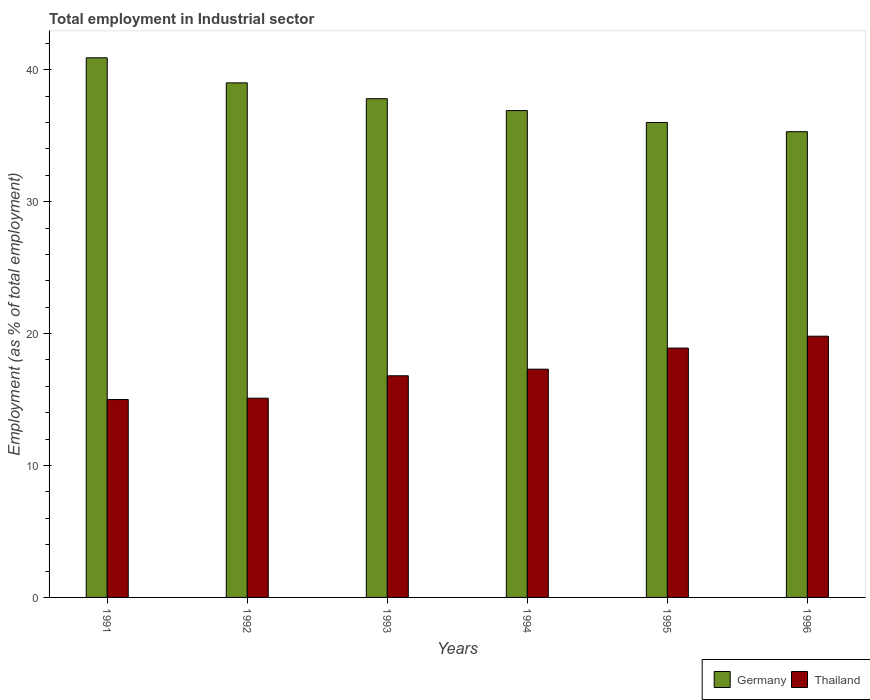How many different coloured bars are there?
Ensure brevity in your answer.  2. How many groups of bars are there?
Offer a terse response. 6. Are the number of bars per tick equal to the number of legend labels?
Offer a terse response. Yes. Are the number of bars on each tick of the X-axis equal?
Provide a short and direct response. Yes. How many bars are there on the 2nd tick from the left?
Your answer should be very brief. 2. What is the label of the 4th group of bars from the left?
Keep it short and to the point. 1994. What is the employment in industrial sector in Thailand in 1993?
Offer a very short reply. 16.8. Across all years, what is the maximum employment in industrial sector in Thailand?
Ensure brevity in your answer.  19.8. In which year was the employment in industrial sector in Thailand maximum?
Offer a terse response. 1996. In which year was the employment in industrial sector in Germany minimum?
Make the answer very short. 1996. What is the total employment in industrial sector in Thailand in the graph?
Make the answer very short. 102.9. What is the difference between the employment in industrial sector in Germany in 1992 and that in 1994?
Provide a succinct answer. 2.1. What is the difference between the employment in industrial sector in Germany in 1993 and the employment in industrial sector in Thailand in 1996?
Offer a very short reply. 18. What is the average employment in industrial sector in Thailand per year?
Ensure brevity in your answer.  17.15. In the year 1993, what is the difference between the employment in industrial sector in Germany and employment in industrial sector in Thailand?
Give a very brief answer. 21. In how many years, is the employment in industrial sector in Germany greater than 36 %?
Your answer should be very brief. 4. What is the ratio of the employment in industrial sector in Thailand in 1991 to that in 1996?
Make the answer very short. 0.76. Is the employment in industrial sector in Thailand in 1992 less than that in 1993?
Keep it short and to the point. Yes. Is the difference between the employment in industrial sector in Germany in 1991 and 1996 greater than the difference between the employment in industrial sector in Thailand in 1991 and 1996?
Your answer should be very brief. Yes. What is the difference between the highest and the second highest employment in industrial sector in Thailand?
Ensure brevity in your answer.  0.9. What is the difference between the highest and the lowest employment in industrial sector in Germany?
Give a very brief answer. 5.6. What does the 1st bar from the left in 1992 represents?
Make the answer very short. Germany. Are all the bars in the graph horizontal?
Give a very brief answer. No. How many years are there in the graph?
Offer a very short reply. 6. What is the difference between two consecutive major ticks on the Y-axis?
Keep it short and to the point. 10. Are the values on the major ticks of Y-axis written in scientific E-notation?
Ensure brevity in your answer.  No. Does the graph contain grids?
Make the answer very short. No. Where does the legend appear in the graph?
Keep it short and to the point. Bottom right. How many legend labels are there?
Your answer should be very brief. 2. How are the legend labels stacked?
Make the answer very short. Horizontal. What is the title of the graph?
Offer a terse response. Total employment in Industrial sector. What is the label or title of the Y-axis?
Your response must be concise. Employment (as % of total employment). What is the Employment (as % of total employment) of Germany in 1991?
Keep it short and to the point. 40.9. What is the Employment (as % of total employment) of Thailand in 1991?
Offer a terse response. 15. What is the Employment (as % of total employment) in Germany in 1992?
Provide a short and direct response. 39. What is the Employment (as % of total employment) of Thailand in 1992?
Provide a short and direct response. 15.1. What is the Employment (as % of total employment) of Germany in 1993?
Give a very brief answer. 37.8. What is the Employment (as % of total employment) of Thailand in 1993?
Offer a terse response. 16.8. What is the Employment (as % of total employment) in Germany in 1994?
Keep it short and to the point. 36.9. What is the Employment (as % of total employment) of Thailand in 1994?
Offer a very short reply. 17.3. What is the Employment (as % of total employment) in Germany in 1995?
Offer a terse response. 36. What is the Employment (as % of total employment) of Thailand in 1995?
Provide a succinct answer. 18.9. What is the Employment (as % of total employment) in Germany in 1996?
Ensure brevity in your answer.  35.3. What is the Employment (as % of total employment) of Thailand in 1996?
Give a very brief answer. 19.8. Across all years, what is the maximum Employment (as % of total employment) in Germany?
Your response must be concise. 40.9. Across all years, what is the maximum Employment (as % of total employment) in Thailand?
Keep it short and to the point. 19.8. Across all years, what is the minimum Employment (as % of total employment) of Germany?
Offer a terse response. 35.3. Across all years, what is the minimum Employment (as % of total employment) in Thailand?
Make the answer very short. 15. What is the total Employment (as % of total employment) of Germany in the graph?
Ensure brevity in your answer.  225.9. What is the total Employment (as % of total employment) in Thailand in the graph?
Offer a very short reply. 102.9. What is the difference between the Employment (as % of total employment) of Germany in 1991 and that in 1992?
Your response must be concise. 1.9. What is the difference between the Employment (as % of total employment) in Germany in 1991 and that in 1993?
Keep it short and to the point. 3.1. What is the difference between the Employment (as % of total employment) of Germany in 1991 and that in 1994?
Offer a very short reply. 4. What is the difference between the Employment (as % of total employment) of Thailand in 1991 and that in 1994?
Ensure brevity in your answer.  -2.3. What is the difference between the Employment (as % of total employment) in Germany in 1991 and that in 1995?
Offer a terse response. 4.9. What is the difference between the Employment (as % of total employment) in Thailand in 1991 and that in 1995?
Make the answer very short. -3.9. What is the difference between the Employment (as % of total employment) in Germany in 1992 and that in 1993?
Make the answer very short. 1.2. What is the difference between the Employment (as % of total employment) in Thailand in 1992 and that in 1993?
Ensure brevity in your answer.  -1.7. What is the difference between the Employment (as % of total employment) in Germany in 1992 and that in 1994?
Give a very brief answer. 2.1. What is the difference between the Employment (as % of total employment) of Thailand in 1992 and that in 1996?
Your answer should be very brief. -4.7. What is the difference between the Employment (as % of total employment) of Germany in 1993 and that in 1994?
Provide a succinct answer. 0.9. What is the difference between the Employment (as % of total employment) in Germany in 1993 and that in 1995?
Give a very brief answer. 1.8. What is the difference between the Employment (as % of total employment) in Thailand in 1993 and that in 1995?
Ensure brevity in your answer.  -2.1. What is the difference between the Employment (as % of total employment) of Germany in 1993 and that in 1996?
Your answer should be very brief. 2.5. What is the difference between the Employment (as % of total employment) of Thailand in 1993 and that in 1996?
Keep it short and to the point. -3. What is the difference between the Employment (as % of total employment) in Germany in 1994 and that in 1995?
Provide a short and direct response. 0.9. What is the difference between the Employment (as % of total employment) of Germany in 1994 and that in 1996?
Keep it short and to the point. 1.6. What is the difference between the Employment (as % of total employment) of Thailand in 1994 and that in 1996?
Your answer should be compact. -2.5. What is the difference between the Employment (as % of total employment) of Thailand in 1995 and that in 1996?
Keep it short and to the point. -0.9. What is the difference between the Employment (as % of total employment) of Germany in 1991 and the Employment (as % of total employment) of Thailand in 1992?
Offer a terse response. 25.8. What is the difference between the Employment (as % of total employment) of Germany in 1991 and the Employment (as % of total employment) of Thailand in 1993?
Ensure brevity in your answer.  24.1. What is the difference between the Employment (as % of total employment) of Germany in 1991 and the Employment (as % of total employment) of Thailand in 1994?
Give a very brief answer. 23.6. What is the difference between the Employment (as % of total employment) in Germany in 1991 and the Employment (as % of total employment) in Thailand in 1996?
Keep it short and to the point. 21.1. What is the difference between the Employment (as % of total employment) in Germany in 1992 and the Employment (as % of total employment) in Thailand in 1993?
Keep it short and to the point. 22.2. What is the difference between the Employment (as % of total employment) in Germany in 1992 and the Employment (as % of total employment) in Thailand in 1994?
Make the answer very short. 21.7. What is the difference between the Employment (as % of total employment) in Germany in 1992 and the Employment (as % of total employment) in Thailand in 1995?
Offer a terse response. 20.1. What is the difference between the Employment (as % of total employment) of Germany in 1993 and the Employment (as % of total employment) of Thailand in 1995?
Provide a succinct answer. 18.9. What is the difference between the Employment (as % of total employment) in Germany in 1993 and the Employment (as % of total employment) in Thailand in 1996?
Your response must be concise. 18. What is the difference between the Employment (as % of total employment) of Germany in 1995 and the Employment (as % of total employment) of Thailand in 1996?
Give a very brief answer. 16.2. What is the average Employment (as % of total employment) of Germany per year?
Your answer should be very brief. 37.65. What is the average Employment (as % of total employment) of Thailand per year?
Give a very brief answer. 17.15. In the year 1991, what is the difference between the Employment (as % of total employment) in Germany and Employment (as % of total employment) in Thailand?
Keep it short and to the point. 25.9. In the year 1992, what is the difference between the Employment (as % of total employment) in Germany and Employment (as % of total employment) in Thailand?
Provide a short and direct response. 23.9. In the year 1993, what is the difference between the Employment (as % of total employment) in Germany and Employment (as % of total employment) in Thailand?
Provide a short and direct response. 21. In the year 1994, what is the difference between the Employment (as % of total employment) in Germany and Employment (as % of total employment) in Thailand?
Provide a succinct answer. 19.6. In the year 1995, what is the difference between the Employment (as % of total employment) of Germany and Employment (as % of total employment) of Thailand?
Offer a very short reply. 17.1. What is the ratio of the Employment (as % of total employment) of Germany in 1991 to that in 1992?
Give a very brief answer. 1.05. What is the ratio of the Employment (as % of total employment) of Germany in 1991 to that in 1993?
Offer a very short reply. 1.08. What is the ratio of the Employment (as % of total employment) of Thailand in 1991 to that in 1993?
Keep it short and to the point. 0.89. What is the ratio of the Employment (as % of total employment) of Germany in 1991 to that in 1994?
Offer a terse response. 1.11. What is the ratio of the Employment (as % of total employment) in Thailand in 1991 to that in 1994?
Give a very brief answer. 0.87. What is the ratio of the Employment (as % of total employment) in Germany in 1991 to that in 1995?
Ensure brevity in your answer.  1.14. What is the ratio of the Employment (as % of total employment) of Thailand in 1991 to that in 1995?
Ensure brevity in your answer.  0.79. What is the ratio of the Employment (as % of total employment) in Germany in 1991 to that in 1996?
Make the answer very short. 1.16. What is the ratio of the Employment (as % of total employment) in Thailand in 1991 to that in 1996?
Offer a very short reply. 0.76. What is the ratio of the Employment (as % of total employment) of Germany in 1992 to that in 1993?
Your answer should be compact. 1.03. What is the ratio of the Employment (as % of total employment) in Thailand in 1992 to that in 1993?
Offer a very short reply. 0.9. What is the ratio of the Employment (as % of total employment) in Germany in 1992 to that in 1994?
Keep it short and to the point. 1.06. What is the ratio of the Employment (as % of total employment) of Thailand in 1992 to that in 1994?
Your answer should be very brief. 0.87. What is the ratio of the Employment (as % of total employment) in Germany in 1992 to that in 1995?
Give a very brief answer. 1.08. What is the ratio of the Employment (as % of total employment) in Thailand in 1992 to that in 1995?
Keep it short and to the point. 0.8. What is the ratio of the Employment (as % of total employment) of Germany in 1992 to that in 1996?
Provide a short and direct response. 1.1. What is the ratio of the Employment (as % of total employment) of Thailand in 1992 to that in 1996?
Provide a succinct answer. 0.76. What is the ratio of the Employment (as % of total employment) of Germany in 1993 to that in 1994?
Provide a succinct answer. 1.02. What is the ratio of the Employment (as % of total employment) in Thailand in 1993 to that in 1994?
Give a very brief answer. 0.97. What is the ratio of the Employment (as % of total employment) of Germany in 1993 to that in 1995?
Offer a terse response. 1.05. What is the ratio of the Employment (as % of total employment) of Thailand in 1993 to that in 1995?
Ensure brevity in your answer.  0.89. What is the ratio of the Employment (as % of total employment) in Germany in 1993 to that in 1996?
Ensure brevity in your answer.  1.07. What is the ratio of the Employment (as % of total employment) of Thailand in 1993 to that in 1996?
Provide a succinct answer. 0.85. What is the ratio of the Employment (as % of total employment) in Thailand in 1994 to that in 1995?
Provide a short and direct response. 0.92. What is the ratio of the Employment (as % of total employment) of Germany in 1994 to that in 1996?
Provide a short and direct response. 1.05. What is the ratio of the Employment (as % of total employment) in Thailand in 1994 to that in 1996?
Offer a very short reply. 0.87. What is the ratio of the Employment (as % of total employment) of Germany in 1995 to that in 1996?
Give a very brief answer. 1.02. What is the ratio of the Employment (as % of total employment) of Thailand in 1995 to that in 1996?
Offer a very short reply. 0.95. What is the difference between the highest and the second highest Employment (as % of total employment) of Germany?
Provide a short and direct response. 1.9. What is the difference between the highest and the lowest Employment (as % of total employment) in Thailand?
Ensure brevity in your answer.  4.8. 